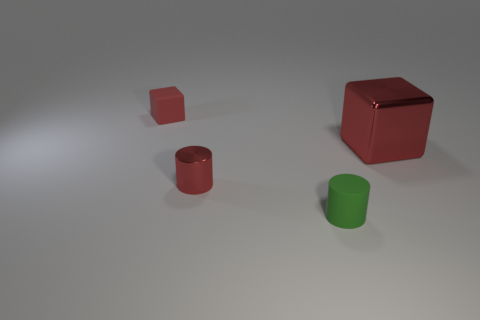Subtract 0 blue balls. How many objects are left? 4 Subtract 2 cylinders. How many cylinders are left? 0 Subtract all yellow cylinders. Subtract all gray blocks. How many cylinders are left? 2 Subtract all cyan balls. How many red cylinders are left? 1 Subtract all cylinders. Subtract all red rubber cubes. How many objects are left? 1 Add 2 small cylinders. How many small cylinders are left? 4 Add 1 large purple rubber balls. How many large purple rubber balls exist? 1 Add 1 small red cylinders. How many objects exist? 5 